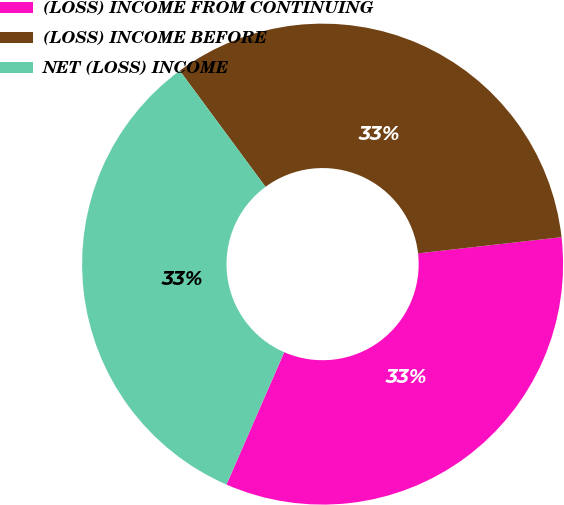Convert chart to OTSL. <chart><loc_0><loc_0><loc_500><loc_500><pie_chart><fcel>(LOSS) INCOME FROM CONTINUING<fcel>(LOSS) INCOME BEFORE<fcel>NET (LOSS) INCOME<nl><fcel>33.33%<fcel>33.33%<fcel>33.33%<nl></chart> 